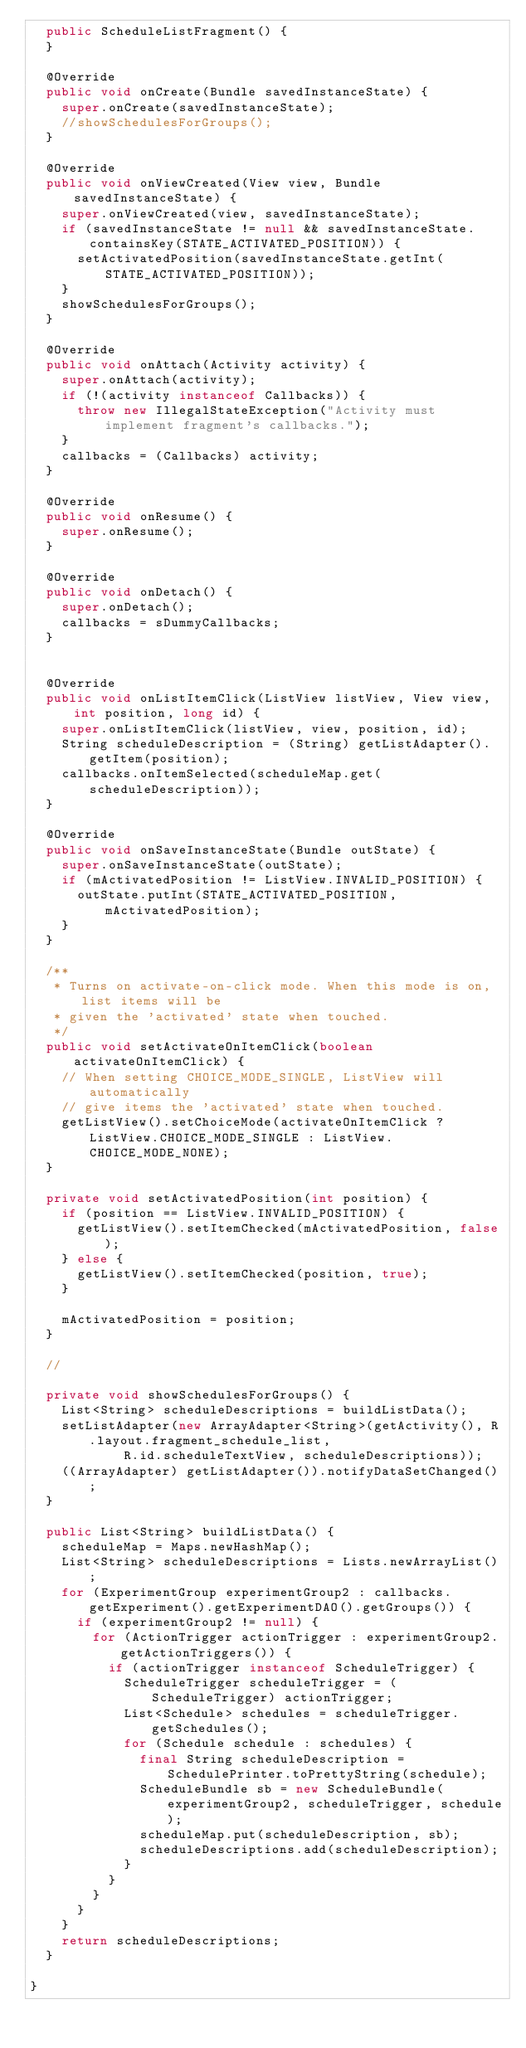<code> <loc_0><loc_0><loc_500><loc_500><_Java_>  public ScheduleListFragment() {
  }

  @Override
  public void onCreate(Bundle savedInstanceState) {
    super.onCreate(savedInstanceState);
    //showSchedulesForGroups();
  }

  @Override
  public void onViewCreated(View view, Bundle savedInstanceState) {
    super.onViewCreated(view, savedInstanceState);
    if (savedInstanceState != null && savedInstanceState.containsKey(STATE_ACTIVATED_POSITION)) {
      setActivatedPosition(savedInstanceState.getInt(STATE_ACTIVATED_POSITION));
    }
    showSchedulesForGroups();
  }

  @Override
  public void onAttach(Activity activity) {
    super.onAttach(activity);
    if (!(activity instanceof Callbacks)) {
      throw new IllegalStateException("Activity must implement fragment's callbacks.");
    }
    callbacks = (Callbacks) activity;
  }

  @Override
  public void onResume() {
    super.onResume();
  }

  @Override
  public void onDetach() {
    super.onDetach();
    callbacks = sDummyCallbacks;
  }


  @Override
  public void onListItemClick(ListView listView, View view, int position, long id) {
    super.onListItemClick(listView, view, position, id);
    String scheduleDescription = (String) getListAdapter().getItem(position);
    callbacks.onItemSelected(scheduleMap.get(scheduleDescription));
  }

  @Override
  public void onSaveInstanceState(Bundle outState) {
    super.onSaveInstanceState(outState);
    if (mActivatedPosition != ListView.INVALID_POSITION) {
      outState.putInt(STATE_ACTIVATED_POSITION, mActivatedPosition);
    }
  }

  /**
   * Turns on activate-on-click mode. When this mode is on, list items will be
   * given the 'activated' state when touched.
   */
  public void setActivateOnItemClick(boolean activateOnItemClick) {
    // When setting CHOICE_MODE_SINGLE, ListView will automatically
    // give items the 'activated' state when touched.
    getListView().setChoiceMode(activateOnItemClick ? ListView.CHOICE_MODE_SINGLE : ListView.CHOICE_MODE_NONE);
  }

  private void setActivatedPosition(int position) {
    if (position == ListView.INVALID_POSITION) {
      getListView().setItemChecked(mActivatedPosition, false);
    } else {
      getListView().setItemChecked(position, true);
    }

    mActivatedPosition = position;
  }

  //

  private void showSchedulesForGroups() {
    List<String> scheduleDescriptions = buildListData();
    setListAdapter(new ArrayAdapter<String>(getActivity(), R.layout.fragment_schedule_list,
            R.id.scheduleTextView, scheduleDescriptions));
    ((ArrayAdapter) getListAdapter()).notifyDataSetChanged();
  }

  public List<String> buildListData() {
    scheduleMap = Maps.newHashMap();
    List<String> scheduleDescriptions = Lists.newArrayList();
    for (ExperimentGroup experimentGroup2 : callbacks.getExperiment().getExperimentDAO().getGroups()) {
      if (experimentGroup2 != null) {
        for (ActionTrigger actionTrigger : experimentGroup2.getActionTriggers()) {
          if (actionTrigger instanceof ScheduleTrigger) {
            ScheduleTrigger scheduleTrigger = (ScheduleTrigger) actionTrigger;
            List<Schedule> schedules = scheduleTrigger.getSchedules();
            for (Schedule schedule : schedules) {
              final String scheduleDescription = SchedulePrinter.toPrettyString(schedule);
              ScheduleBundle sb = new ScheduleBundle(experimentGroup2, scheduleTrigger, schedule);
              scheduleMap.put(scheduleDescription, sb);
              scheduleDescriptions.add(scheduleDescription);
            }
          }
        }
      }
    }
    return scheduleDescriptions;
  }

}
</code> 